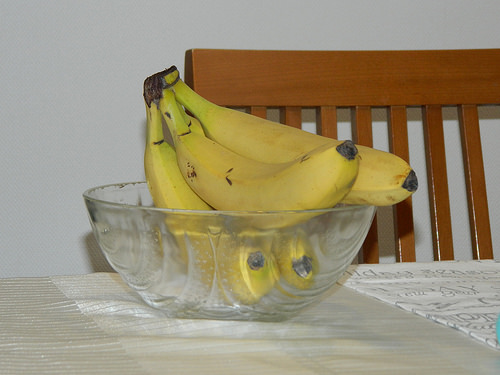<image>
Can you confirm if the banana is on the table? Yes. Looking at the image, I can see the banana is positioned on top of the table, with the table providing support. 